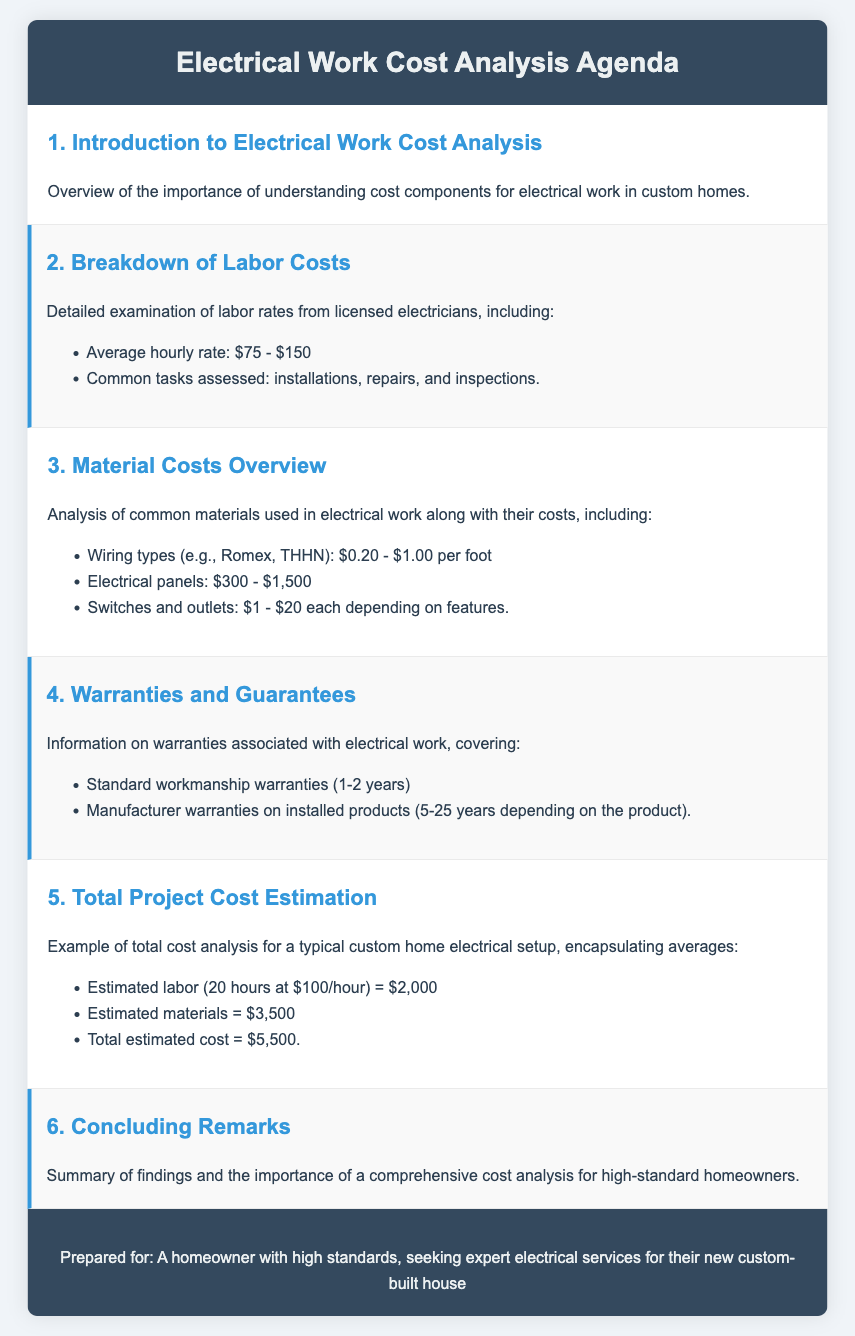What is the average hourly labor rate? The average hourly labor rate for licensed electricians ranges from $75 to $150 as detailed in the document.
Answer: $75 - $150 What is included in the standard workmanship warranties? The document states that standard workmanship warranties typically cover a duration of 1-2 years.
Answer: 1-2 years What is the estimated labor cost for a typical custom home electrical setup? The document presents the estimated labor cost as calculated from 20 hours at $100/hour.
Answer: $2,000 What are the common types of wiring mentioned? The document specifically lists Romex and THHN as common wiring types used in electrical work.
Answer: Romex, THHN What is the total estimated cost for the electrical setup? The total estimated cost is a summation of estimated labor and materials, specified in the document.
Answer: $5,500 How long can manufacturer warranties on installed products last? The document indicates that manufacturer warranties may last from 5 to 25 years, depending on the product.
Answer: 5-25 years What section details the breakdown of labor costs? The section that details labor costs is titled "Breakdown of Labor Costs" in the agenda.
Answer: Breakdown of Labor Costs What is the average cost range for electrical panels? According to the document, the average cost for electrical panels ranges from $300 to $1,500.
Answer: $300 - $1,500 What is the importance emphasized in the concluding remarks? The concluding remarks highlight the importance of a thorough cost analysis for homeowners with high standards.
Answer: Comprehensive cost analysis 